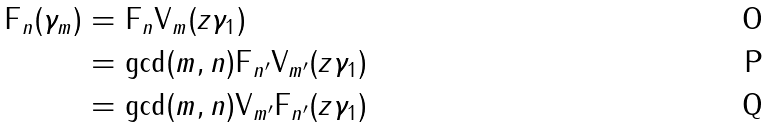Convert formula to latex. <formula><loc_0><loc_0><loc_500><loc_500>\text {F} _ { n } ( \gamma _ { m } ) & = \text {F} _ { n } \text {V} _ { m } ( z \gamma _ { 1 } ) \\ & = \text {gcd} ( m , n ) \text {F} _ { n ^ { \prime } } \text {V} _ { m ^ { \prime } } ( z \gamma _ { 1 } ) \\ & = \text {gcd} ( m , n ) \text {V} _ { m ^ { \prime } } \text {F} _ { n ^ { \prime } } ( z \gamma _ { 1 } )</formula> 